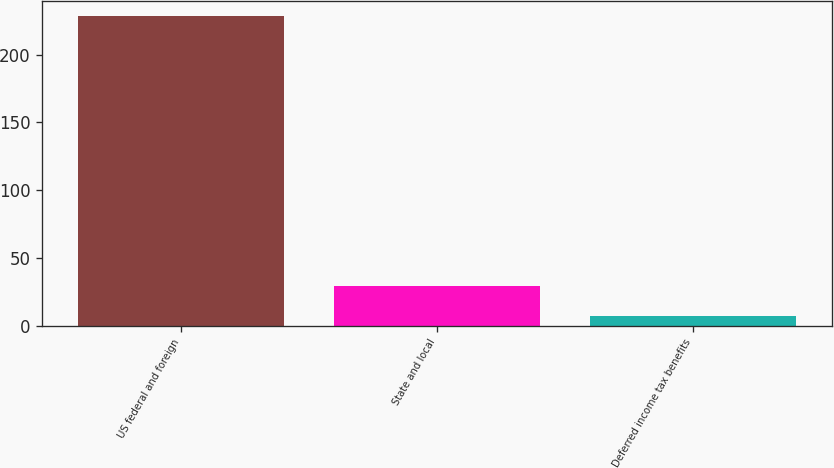Convert chart. <chart><loc_0><loc_0><loc_500><loc_500><bar_chart><fcel>US federal and foreign<fcel>State and local<fcel>Deferred income tax benefits<nl><fcel>228.1<fcel>29.2<fcel>7.1<nl></chart> 